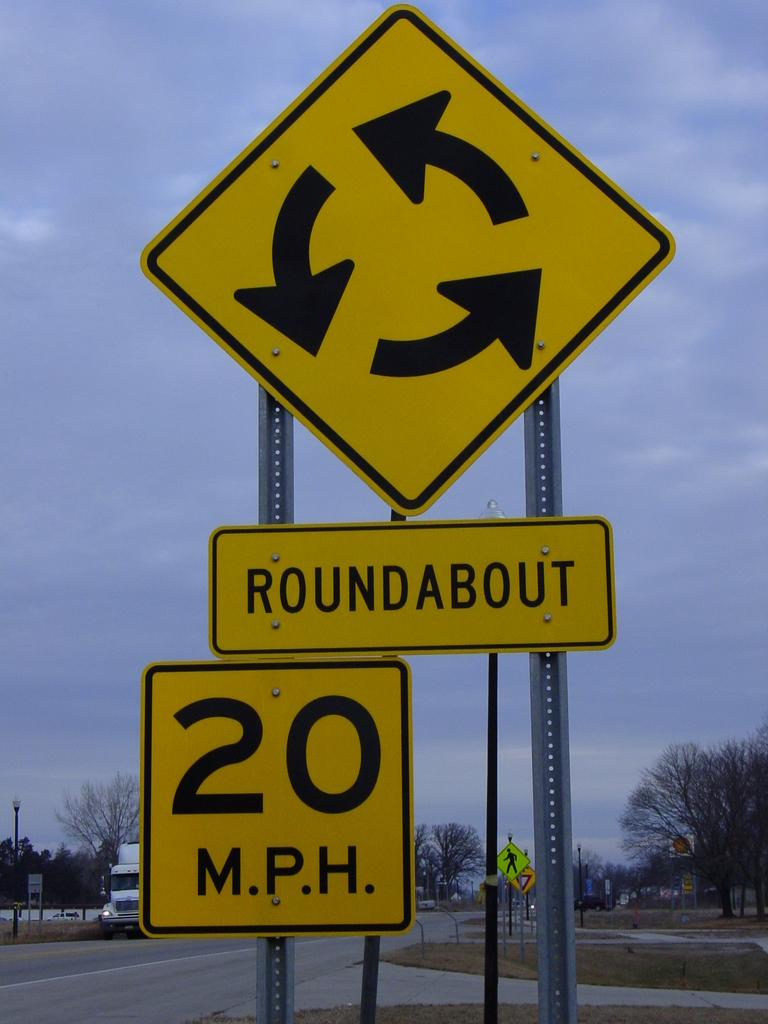<image>
Give a short and clear explanation of the subsequent image. A road sign warns drivers that there is an upcoming roundabout and the speed limit for this is 20 miles per hour. 